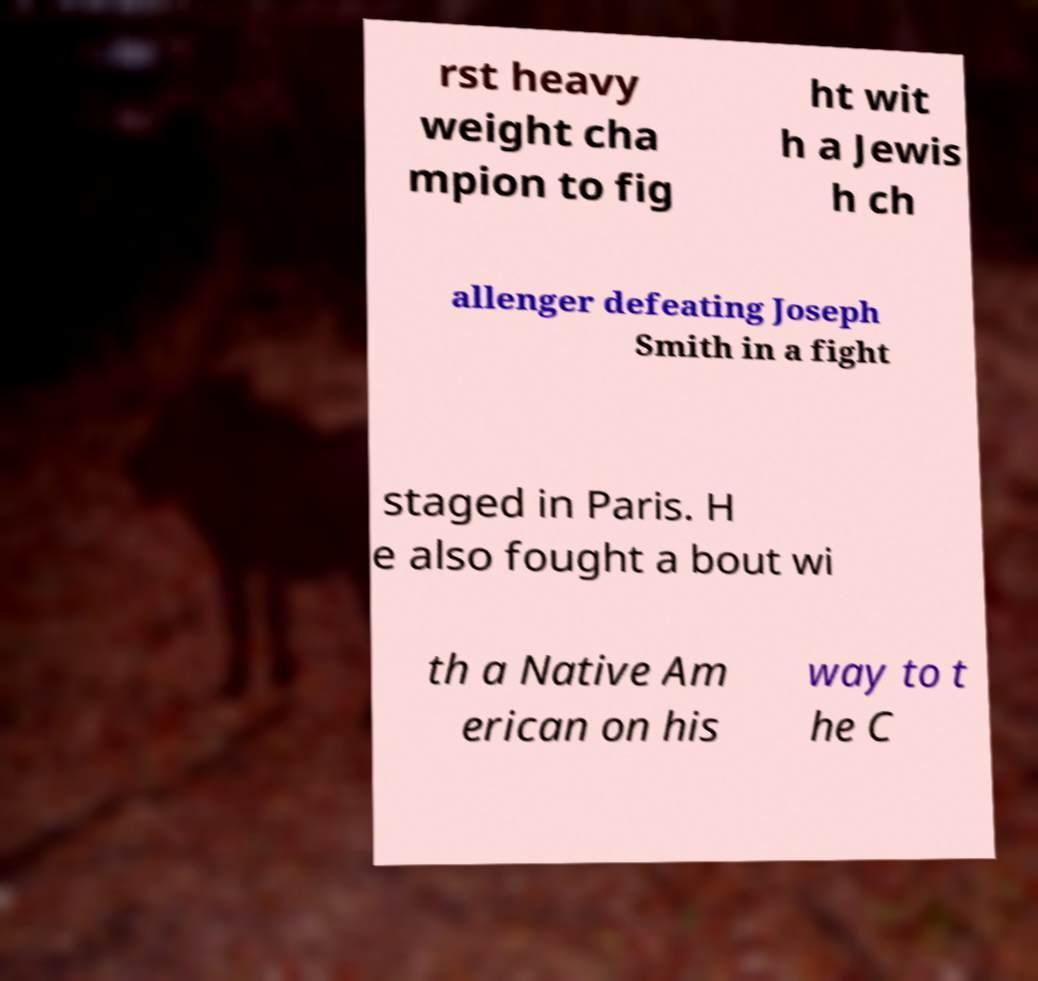Can you accurately transcribe the text from the provided image for me? rst heavy weight cha mpion to fig ht wit h a Jewis h ch allenger defeating Joseph Smith in a fight staged in Paris. H e also fought a bout wi th a Native Am erican on his way to t he C 